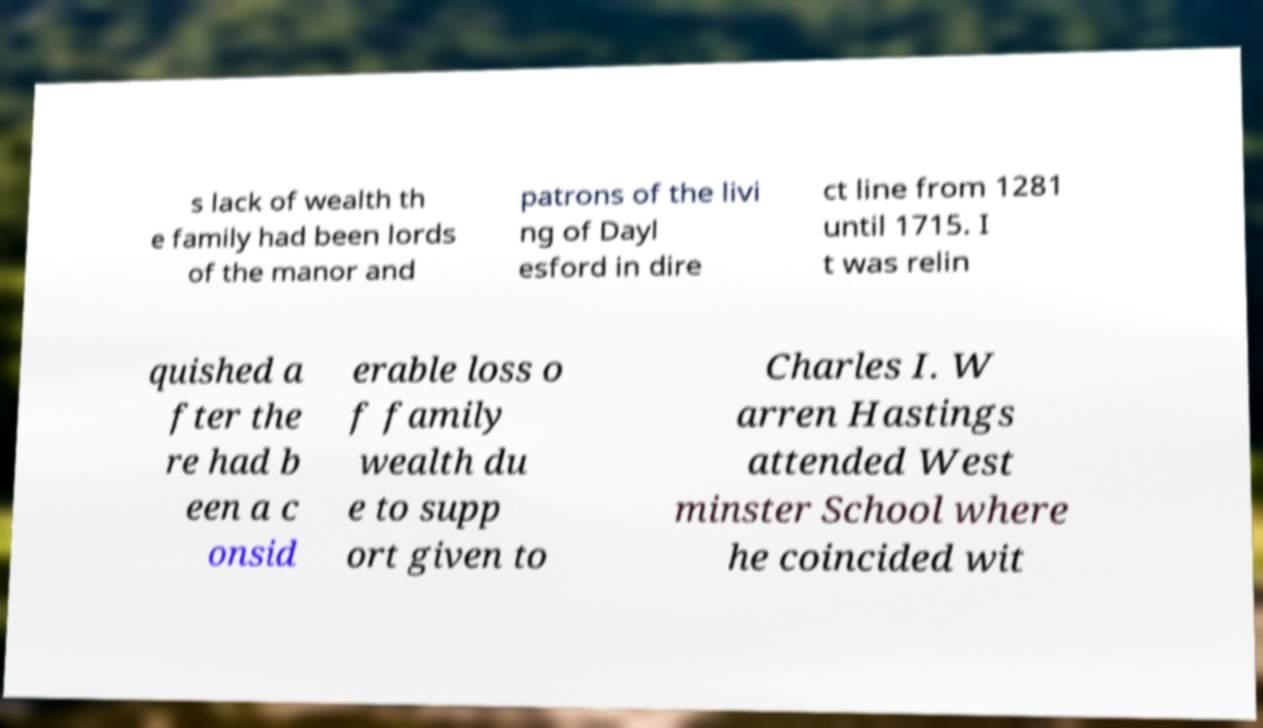Can you accurately transcribe the text from the provided image for me? s lack of wealth th e family had been lords of the manor and patrons of the livi ng of Dayl esford in dire ct line from 1281 until 1715. I t was relin quished a fter the re had b een a c onsid erable loss o f family wealth du e to supp ort given to Charles I. W arren Hastings attended West minster School where he coincided wit 